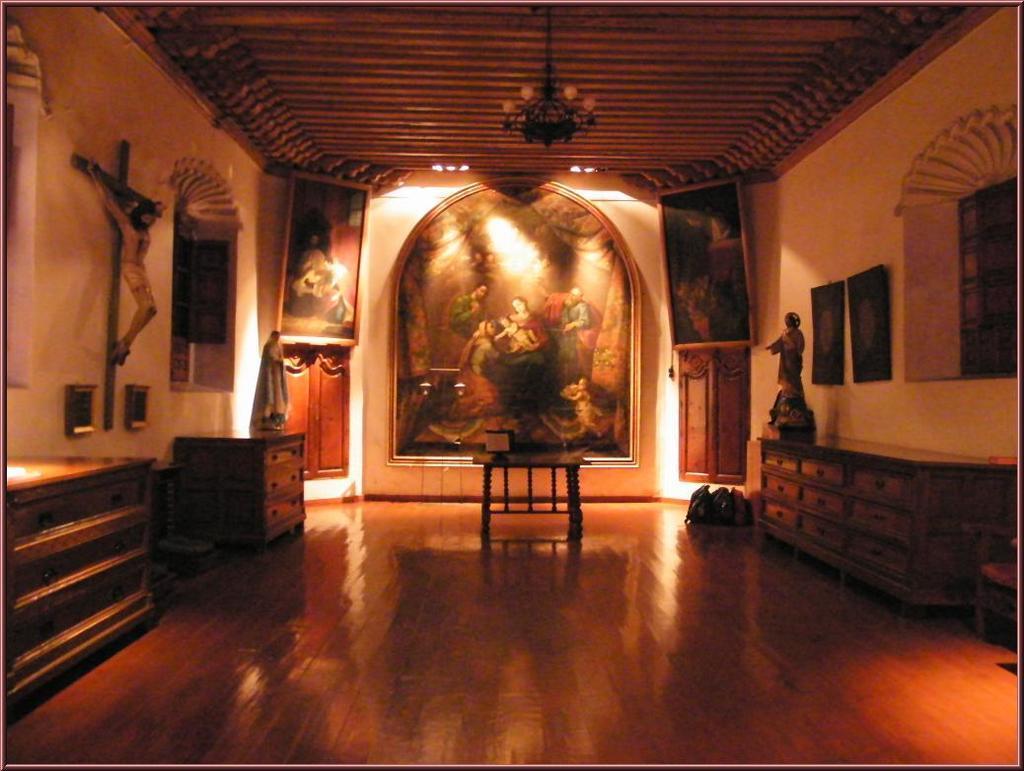Please provide a concise description of this image. In this image i can see a statue on the wall, a table and a chandelier. 